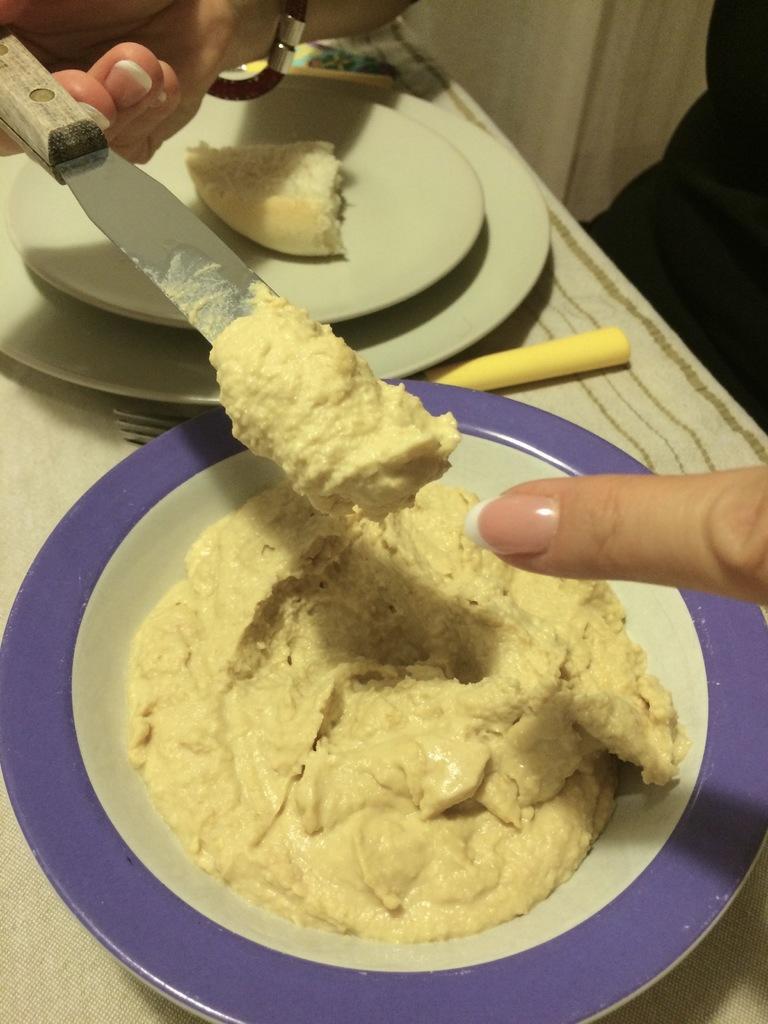Can you describe this image briefly? This image consist of food which is on the plate. On the right side there is a finger of the person. On the top left there is a knife in the hand of the person and there are plates which are white in colour and there is a folk on the table and on the right side there is an object which is black in colour. 